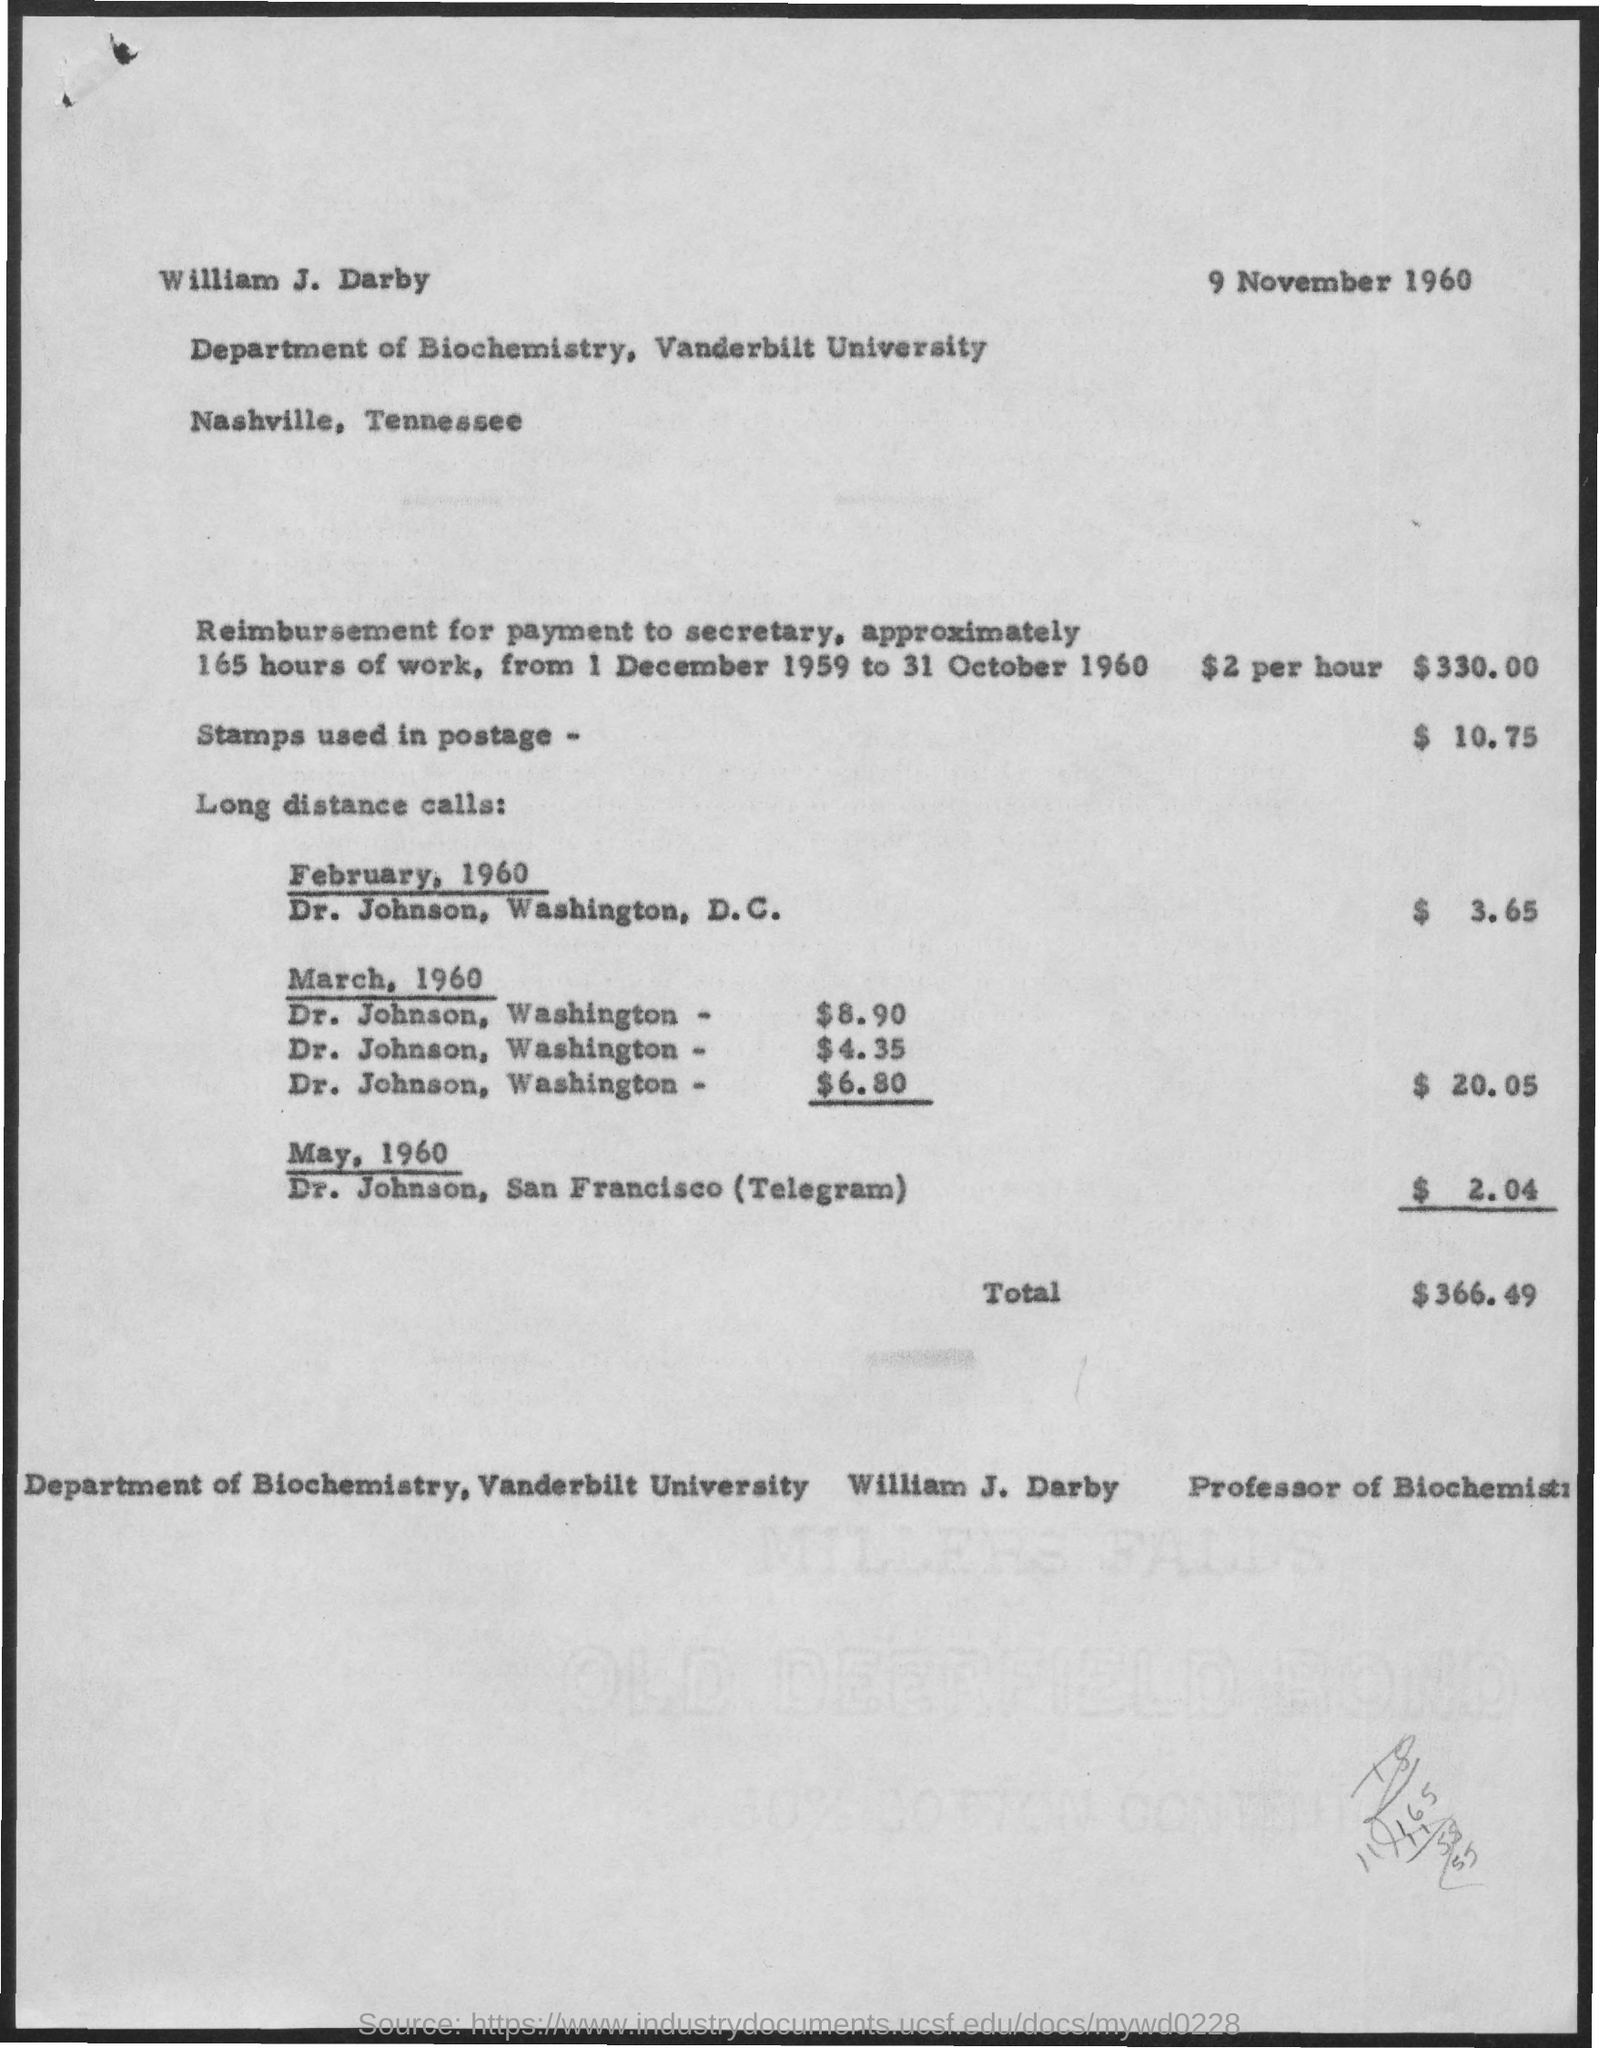Identify some key points in this picture. The date and year mentioned at the top of the page are 9 November 1960. The total amount is $366.49. The amount that is being reimbursed for the payment made to the Secretary for 165 hours of work is $330.00. The cost of stamps used for postage is $10.75. The total charges for long distance calls in March, 1960, were $20.05. 